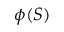Convert formula to latex. <formula><loc_0><loc_0><loc_500><loc_500>\phi ( S )</formula> 